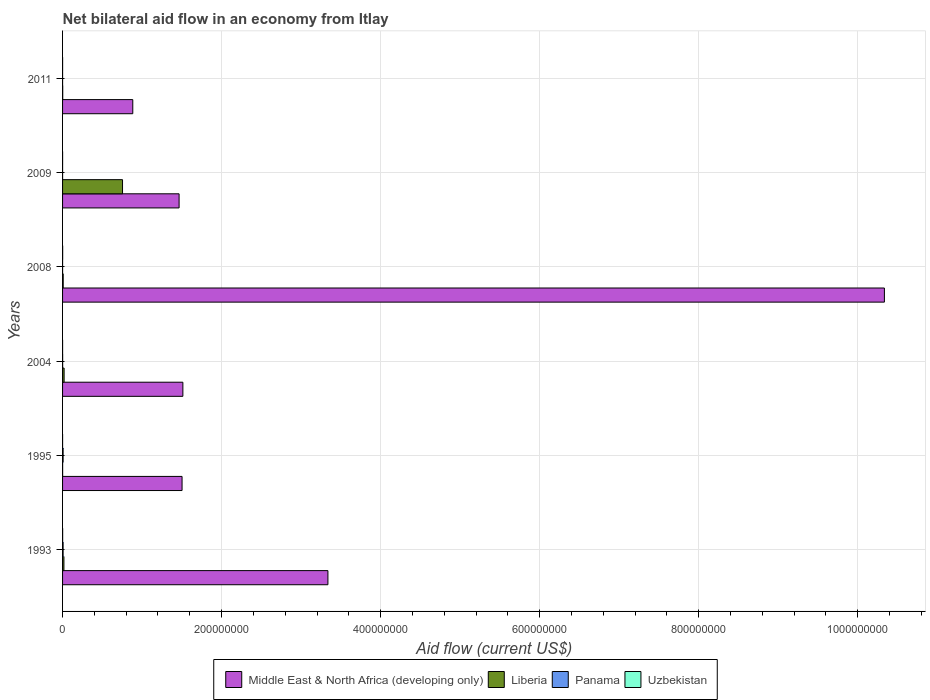Are the number of bars on each tick of the Y-axis equal?
Provide a short and direct response. Yes. What is the net bilateral aid flow in Uzbekistan in 1995?
Offer a very short reply. 10000. Across all years, what is the maximum net bilateral aid flow in Middle East & North Africa (developing only)?
Your answer should be compact. 1.03e+09. In which year was the net bilateral aid flow in Uzbekistan maximum?
Offer a very short reply. 2008. What is the total net bilateral aid flow in Panama in the graph?
Your response must be concise. 1.48e+06. What is the difference between the net bilateral aid flow in Panama in 1993 and the net bilateral aid flow in Middle East & North Africa (developing only) in 2008?
Give a very brief answer. -1.03e+09. What is the average net bilateral aid flow in Middle East & North Africa (developing only) per year?
Your answer should be compact. 3.17e+08. In the year 1995, what is the difference between the net bilateral aid flow in Uzbekistan and net bilateral aid flow in Liberia?
Provide a short and direct response. -7.00e+04. In how many years, is the net bilateral aid flow in Uzbekistan greater than 920000000 US$?
Make the answer very short. 0. What is the ratio of the net bilateral aid flow in Uzbekistan in 1993 to that in 2004?
Your answer should be compact. 9. Is the net bilateral aid flow in Uzbekistan in 1995 less than that in 2008?
Ensure brevity in your answer.  Yes. Is the difference between the net bilateral aid flow in Uzbekistan in 1993 and 2004 greater than the difference between the net bilateral aid flow in Liberia in 1993 and 2004?
Your response must be concise. Yes. What is the difference between the highest and the second highest net bilateral aid flow in Liberia?
Keep it short and to the point. 7.35e+07. What is the difference between the highest and the lowest net bilateral aid flow in Middle East & North Africa (developing only)?
Provide a succinct answer. 9.45e+08. Is it the case that in every year, the sum of the net bilateral aid flow in Uzbekistan and net bilateral aid flow in Middle East & North Africa (developing only) is greater than the sum of net bilateral aid flow in Liberia and net bilateral aid flow in Panama?
Offer a very short reply. Yes. What does the 1st bar from the top in 2004 represents?
Keep it short and to the point. Uzbekistan. What does the 1st bar from the bottom in 1993 represents?
Give a very brief answer. Middle East & North Africa (developing only). Is it the case that in every year, the sum of the net bilateral aid flow in Middle East & North Africa (developing only) and net bilateral aid flow in Liberia is greater than the net bilateral aid flow in Panama?
Make the answer very short. Yes. Are all the bars in the graph horizontal?
Your answer should be very brief. Yes. What is the difference between two consecutive major ticks on the X-axis?
Provide a short and direct response. 2.00e+08. Does the graph contain any zero values?
Keep it short and to the point. No. Does the graph contain grids?
Ensure brevity in your answer.  Yes. Where does the legend appear in the graph?
Keep it short and to the point. Bottom center. How many legend labels are there?
Provide a short and direct response. 4. What is the title of the graph?
Your answer should be very brief. Net bilateral aid flow in an economy from Itlay. Does "Faeroe Islands" appear as one of the legend labels in the graph?
Give a very brief answer. No. What is the Aid flow (current US$) of Middle East & North Africa (developing only) in 1993?
Ensure brevity in your answer.  3.34e+08. What is the Aid flow (current US$) in Liberia in 1993?
Offer a very short reply. 1.71e+06. What is the Aid flow (current US$) of Panama in 1993?
Offer a terse response. 6.80e+05. What is the Aid flow (current US$) in Uzbekistan in 1993?
Offer a terse response. 9.00e+04. What is the Aid flow (current US$) of Middle East & North Africa (developing only) in 1995?
Your answer should be compact. 1.50e+08. What is the Aid flow (current US$) in Panama in 1995?
Make the answer very short. 6.80e+05. What is the Aid flow (current US$) of Middle East & North Africa (developing only) in 2004?
Your response must be concise. 1.51e+08. What is the Aid flow (current US$) in Liberia in 2004?
Your answer should be very brief. 1.95e+06. What is the Aid flow (current US$) in Panama in 2004?
Offer a terse response. 9.00e+04. What is the Aid flow (current US$) in Middle East & North Africa (developing only) in 2008?
Your response must be concise. 1.03e+09. What is the Aid flow (current US$) of Liberia in 2008?
Provide a succinct answer. 8.10e+05. What is the Aid flow (current US$) in Uzbekistan in 2008?
Provide a short and direct response. 1.20e+05. What is the Aid flow (current US$) of Middle East & North Africa (developing only) in 2009?
Provide a short and direct response. 1.47e+08. What is the Aid flow (current US$) of Liberia in 2009?
Offer a terse response. 7.54e+07. What is the Aid flow (current US$) in Middle East & North Africa (developing only) in 2011?
Offer a terse response. 8.83e+07. Across all years, what is the maximum Aid flow (current US$) in Middle East & North Africa (developing only)?
Keep it short and to the point. 1.03e+09. Across all years, what is the maximum Aid flow (current US$) of Liberia?
Your answer should be very brief. 7.54e+07. Across all years, what is the maximum Aid flow (current US$) in Panama?
Give a very brief answer. 6.80e+05. Across all years, what is the minimum Aid flow (current US$) of Middle East & North Africa (developing only)?
Provide a short and direct response. 8.83e+07. What is the total Aid flow (current US$) of Middle East & North Africa (developing only) in the graph?
Provide a succinct answer. 1.90e+09. What is the total Aid flow (current US$) in Liberia in the graph?
Make the answer very short. 8.02e+07. What is the total Aid flow (current US$) in Panama in the graph?
Ensure brevity in your answer.  1.48e+06. What is the difference between the Aid flow (current US$) in Middle East & North Africa (developing only) in 1993 and that in 1995?
Your response must be concise. 1.83e+08. What is the difference between the Aid flow (current US$) of Liberia in 1993 and that in 1995?
Keep it short and to the point. 1.63e+06. What is the difference between the Aid flow (current US$) of Uzbekistan in 1993 and that in 1995?
Provide a short and direct response. 8.00e+04. What is the difference between the Aid flow (current US$) of Middle East & North Africa (developing only) in 1993 and that in 2004?
Offer a very short reply. 1.82e+08. What is the difference between the Aid flow (current US$) of Panama in 1993 and that in 2004?
Give a very brief answer. 5.90e+05. What is the difference between the Aid flow (current US$) in Middle East & North Africa (developing only) in 1993 and that in 2008?
Offer a terse response. -7.00e+08. What is the difference between the Aid flow (current US$) of Liberia in 1993 and that in 2008?
Ensure brevity in your answer.  9.00e+05. What is the difference between the Aid flow (current US$) of Panama in 1993 and that in 2008?
Provide a short and direct response. 6.70e+05. What is the difference between the Aid flow (current US$) of Middle East & North Africa (developing only) in 1993 and that in 2009?
Make the answer very short. 1.87e+08. What is the difference between the Aid flow (current US$) in Liberia in 1993 and that in 2009?
Ensure brevity in your answer.  -7.37e+07. What is the difference between the Aid flow (current US$) in Panama in 1993 and that in 2009?
Keep it short and to the point. 6.70e+05. What is the difference between the Aid flow (current US$) of Middle East & North Africa (developing only) in 1993 and that in 2011?
Make the answer very short. 2.45e+08. What is the difference between the Aid flow (current US$) of Liberia in 1993 and that in 2011?
Your answer should be compact. 1.52e+06. What is the difference between the Aid flow (current US$) in Panama in 1993 and that in 2011?
Ensure brevity in your answer.  6.70e+05. What is the difference between the Aid flow (current US$) in Middle East & North Africa (developing only) in 1995 and that in 2004?
Keep it short and to the point. -1.02e+06. What is the difference between the Aid flow (current US$) in Liberia in 1995 and that in 2004?
Provide a short and direct response. -1.87e+06. What is the difference between the Aid flow (current US$) of Panama in 1995 and that in 2004?
Give a very brief answer. 5.90e+05. What is the difference between the Aid flow (current US$) in Middle East & North Africa (developing only) in 1995 and that in 2008?
Ensure brevity in your answer.  -8.83e+08. What is the difference between the Aid flow (current US$) in Liberia in 1995 and that in 2008?
Your answer should be compact. -7.30e+05. What is the difference between the Aid flow (current US$) of Panama in 1995 and that in 2008?
Keep it short and to the point. 6.70e+05. What is the difference between the Aid flow (current US$) in Uzbekistan in 1995 and that in 2008?
Ensure brevity in your answer.  -1.10e+05. What is the difference between the Aid flow (current US$) in Middle East & North Africa (developing only) in 1995 and that in 2009?
Make the answer very short. 3.73e+06. What is the difference between the Aid flow (current US$) in Liberia in 1995 and that in 2009?
Your answer should be compact. -7.53e+07. What is the difference between the Aid flow (current US$) in Panama in 1995 and that in 2009?
Ensure brevity in your answer.  6.70e+05. What is the difference between the Aid flow (current US$) of Uzbekistan in 1995 and that in 2009?
Your response must be concise. -2.00e+04. What is the difference between the Aid flow (current US$) of Middle East & North Africa (developing only) in 1995 and that in 2011?
Your answer should be very brief. 6.20e+07. What is the difference between the Aid flow (current US$) of Liberia in 1995 and that in 2011?
Provide a short and direct response. -1.10e+05. What is the difference between the Aid flow (current US$) in Panama in 1995 and that in 2011?
Provide a short and direct response. 6.70e+05. What is the difference between the Aid flow (current US$) of Middle East & North Africa (developing only) in 2004 and that in 2008?
Give a very brief answer. -8.82e+08. What is the difference between the Aid flow (current US$) of Liberia in 2004 and that in 2008?
Your answer should be compact. 1.14e+06. What is the difference between the Aid flow (current US$) of Panama in 2004 and that in 2008?
Your answer should be very brief. 8.00e+04. What is the difference between the Aid flow (current US$) in Middle East & North Africa (developing only) in 2004 and that in 2009?
Offer a very short reply. 4.75e+06. What is the difference between the Aid flow (current US$) in Liberia in 2004 and that in 2009?
Offer a terse response. -7.35e+07. What is the difference between the Aid flow (current US$) of Panama in 2004 and that in 2009?
Keep it short and to the point. 8.00e+04. What is the difference between the Aid flow (current US$) of Uzbekistan in 2004 and that in 2009?
Ensure brevity in your answer.  -2.00e+04. What is the difference between the Aid flow (current US$) in Middle East & North Africa (developing only) in 2004 and that in 2011?
Make the answer very short. 6.30e+07. What is the difference between the Aid flow (current US$) of Liberia in 2004 and that in 2011?
Make the answer very short. 1.76e+06. What is the difference between the Aid flow (current US$) in Panama in 2004 and that in 2011?
Offer a terse response. 8.00e+04. What is the difference between the Aid flow (current US$) in Uzbekistan in 2004 and that in 2011?
Keep it short and to the point. -2.00e+04. What is the difference between the Aid flow (current US$) in Middle East & North Africa (developing only) in 2008 and that in 2009?
Give a very brief answer. 8.87e+08. What is the difference between the Aid flow (current US$) of Liberia in 2008 and that in 2009?
Provide a short and direct response. -7.46e+07. What is the difference between the Aid flow (current US$) of Panama in 2008 and that in 2009?
Make the answer very short. 0. What is the difference between the Aid flow (current US$) of Uzbekistan in 2008 and that in 2009?
Offer a very short reply. 9.00e+04. What is the difference between the Aid flow (current US$) in Middle East & North Africa (developing only) in 2008 and that in 2011?
Provide a short and direct response. 9.45e+08. What is the difference between the Aid flow (current US$) in Liberia in 2008 and that in 2011?
Make the answer very short. 6.20e+05. What is the difference between the Aid flow (current US$) of Panama in 2008 and that in 2011?
Your answer should be very brief. 0. What is the difference between the Aid flow (current US$) of Uzbekistan in 2008 and that in 2011?
Your answer should be compact. 9.00e+04. What is the difference between the Aid flow (current US$) of Middle East & North Africa (developing only) in 2009 and that in 2011?
Offer a very short reply. 5.82e+07. What is the difference between the Aid flow (current US$) of Liberia in 2009 and that in 2011?
Keep it short and to the point. 7.52e+07. What is the difference between the Aid flow (current US$) in Middle East & North Africa (developing only) in 1993 and the Aid flow (current US$) in Liberia in 1995?
Make the answer very short. 3.34e+08. What is the difference between the Aid flow (current US$) in Middle East & North Africa (developing only) in 1993 and the Aid flow (current US$) in Panama in 1995?
Keep it short and to the point. 3.33e+08. What is the difference between the Aid flow (current US$) in Middle East & North Africa (developing only) in 1993 and the Aid flow (current US$) in Uzbekistan in 1995?
Make the answer very short. 3.34e+08. What is the difference between the Aid flow (current US$) in Liberia in 1993 and the Aid flow (current US$) in Panama in 1995?
Your response must be concise. 1.03e+06. What is the difference between the Aid flow (current US$) of Liberia in 1993 and the Aid flow (current US$) of Uzbekistan in 1995?
Offer a very short reply. 1.70e+06. What is the difference between the Aid flow (current US$) in Panama in 1993 and the Aid flow (current US$) in Uzbekistan in 1995?
Your response must be concise. 6.70e+05. What is the difference between the Aid flow (current US$) in Middle East & North Africa (developing only) in 1993 and the Aid flow (current US$) in Liberia in 2004?
Your response must be concise. 3.32e+08. What is the difference between the Aid flow (current US$) in Middle East & North Africa (developing only) in 1993 and the Aid flow (current US$) in Panama in 2004?
Make the answer very short. 3.34e+08. What is the difference between the Aid flow (current US$) in Middle East & North Africa (developing only) in 1993 and the Aid flow (current US$) in Uzbekistan in 2004?
Provide a succinct answer. 3.34e+08. What is the difference between the Aid flow (current US$) of Liberia in 1993 and the Aid flow (current US$) of Panama in 2004?
Provide a succinct answer. 1.62e+06. What is the difference between the Aid flow (current US$) of Liberia in 1993 and the Aid flow (current US$) of Uzbekistan in 2004?
Offer a terse response. 1.70e+06. What is the difference between the Aid flow (current US$) of Panama in 1993 and the Aid flow (current US$) of Uzbekistan in 2004?
Make the answer very short. 6.70e+05. What is the difference between the Aid flow (current US$) of Middle East & North Africa (developing only) in 1993 and the Aid flow (current US$) of Liberia in 2008?
Keep it short and to the point. 3.33e+08. What is the difference between the Aid flow (current US$) of Middle East & North Africa (developing only) in 1993 and the Aid flow (current US$) of Panama in 2008?
Make the answer very short. 3.34e+08. What is the difference between the Aid flow (current US$) of Middle East & North Africa (developing only) in 1993 and the Aid flow (current US$) of Uzbekistan in 2008?
Provide a succinct answer. 3.34e+08. What is the difference between the Aid flow (current US$) in Liberia in 1993 and the Aid flow (current US$) in Panama in 2008?
Your answer should be very brief. 1.70e+06. What is the difference between the Aid flow (current US$) in Liberia in 1993 and the Aid flow (current US$) in Uzbekistan in 2008?
Keep it short and to the point. 1.59e+06. What is the difference between the Aid flow (current US$) in Panama in 1993 and the Aid flow (current US$) in Uzbekistan in 2008?
Offer a terse response. 5.60e+05. What is the difference between the Aid flow (current US$) in Middle East & North Africa (developing only) in 1993 and the Aid flow (current US$) in Liberia in 2009?
Your response must be concise. 2.58e+08. What is the difference between the Aid flow (current US$) in Middle East & North Africa (developing only) in 1993 and the Aid flow (current US$) in Panama in 2009?
Your response must be concise. 3.34e+08. What is the difference between the Aid flow (current US$) of Middle East & North Africa (developing only) in 1993 and the Aid flow (current US$) of Uzbekistan in 2009?
Your answer should be very brief. 3.34e+08. What is the difference between the Aid flow (current US$) in Liberia in 1993 and the Aid flow (current US$) in Panama in 2009?
Ensure brevity in your answer.  1.70e+06. What is the difference between the Aid flow (current US$) of Liberia in 1993 and the Aid flow (current US$) of Uzbekistan in 2009?
Your answer should be very brief. 1.68e+06. What is the difference between the Aid flow (current US$) in Panama in 1993 and the Aid flow (current US$) in Uzbekistan in 2009?
Make the answer very short. 6.50e+05. What is the difference between the Aid flow (current US$) in Middle East & North Africa (developing only) in 1993 and the Aid flow (current US$) in Liberia in 2011?
Your answer should be compact. 3.34e+08. What is the difference between the Aid flow (current US$) in Middle East & North Africa (developing only) in 1993 and the Aid flow (current US$) in Panama in 2011?
Provide a succinct answer. 3.34e+08. What is the difference between the Aid flow (current US$) in Middle East & North Africa (developing only) in 1993 and the Aid flow (current US$) in Uzbekistan in 2011?
Keep it short and to the point. 3.34e+08. What is the difference between the Aid flow (current US$) in Liberia in 1993 and the Aid flow (current US$) in Panama in 2011?
Ensure brevity in your answer.  1.70e+06. What is the difference between the Aid flow (current US$) of Liberia in 1993 and the Aid flow (current US$) of Uzbekistan in 2011?
Make the answer very short. 1.68e+06. What is the difference between the Aid flow (current US$) in Panama in 1993 and the Aid flow (current US$) in Uzbekistan in 2011?
Keep it short and to the point. 6.50e+05. What is the difference between the Aid flow (current US$) in Middle East & North Africa (developing only) in 1995 and the Aid flow (current US$) in Liberia in 2004?
Offer a very short reply. 1.48e+08. What is the difference between the Aid flow (current US$) of Middle East & North Africa (developing only) in 1995 and the Aid flow (current US$) of Panama in 2004?
Your answer should be very brief. 1.50e+08. What is the difference between the Aid flow (current US$) in Middle East & North Africa (developing only) in 1995 and the Aid flow (current US$) in Uzbekistan in 2004?
Give a very brief answer. 1.50e+08. What is the difference between the Aid flow (current US$) in Liberia in 1995 and the Aid flow (current US$) in Panama in 2004?
Make the answer very short. -10000. What is the difference between the Aid flow (current US$) in Liberia in 1995 and the Aid flow (current US$) in Uzbekistan in 2004?
Give a very brief answer. 7.00e+04. What is the difference between the Aid flow (current US$) in Panama in 1995 and the Aid flow (current US$) in Uzbekistan in 2004?
Ensure brevity in your answer.  6.70e+05. What is the difference between the Aid flow (current US$) of Middle East & North Africa (developing only) in 1995 and the Aid flow (current US$) of Liberia in 2008?
Provide a succinct answer. 1.49e+08. What is the difference between the Aid flow (current US$) in Middle East & North Africa (developing only) in 1995 and the Aid flow (current US$) in Panama in 2008?
Your answer should be very brief. 1.50e+08. What is the difference between the Aid flow (current US$) of Middle East & North Africa (developing only) in 1995 and the Aid flow (current US$) of Uzbekistan in 2008?
Give a very brief answer. 1.50e+08. What is the difference between the Aid flow (current US$) of Liberia in 1995 and the Aid flow (current US$) of Uzbekistan in 2008?
Ensure brevity in your answer.  -4.00e+04. What is the difference between the Aid flow (current US$) of Panama in 1995 and the Aid flow (current US$) of Uzbekistan in 2008?
Your answer should be very brief. 5.60e+05. What is the difference between the Aid flow (current US$) in Middle East & North Africa (developing only) in 1995 and the Aid flow (current US$) in Liberia in 2009?
Your response must be concise. 7.49e+07. What is the difference between the Aid flow (current US$) in Middle East & North Africa (developing only) in 1995 and the Aid flow (current US$) in Panama in 2009?
Provide a short and direct response. 1.50e+08. What is the difference between the Aid flow (current US$) of Middle East & North Africa (developing only) in 1995 and the Aid flow (current US$) of Uzbekistan in 2009?
Offer a very short reply. 1.50e+08. What is the difference between the Aid flow (current US$) in Liberia in 1995 and the Aid flow (current US$) in Uzbekistan in 2009?
Ensure brevity in your answer.  5.00e+04. What is the difference between the Aid flow (current US$) in Panama in 1995 and the Aid flow (current US$) in Uzbekistan in 2009?
Ensure brevity in your answer.  6.50e+05. What is the difference between the Aid flow (current US$) in Middle East & North Africa (developing only) in 1995 and the Aid flow (current US$) in Liberia in 2011?
Provide a short and direct response. 1.50e+08. What is the difference between the Aid flow (current US$) in Middle East & North Africa (developing only) in 1995 and the Aid flow (current US$) in Panama in 2011?
Your answer should be very brief. 1.50e+08. What is the difference between the Aid flow (current US$) of Middle East & North Africa (developing only) in 1995 and the Aid flow (current US$) of Uzbekistan in 2011?
Your response must be concise. 1.50e+08. What is the difference between the Aid flow (current US$) in Liberia in 1995 and the Aid flow (current US$) in Panama in 2011?
Offer a terse response. 7.00e+04. What is the difference between the Aid flow (current US$) of Liberia in 1995 and the Aid flow (current US$) of Uzbekistan in 2011?
Provide a succinct answer. 5.00e+04. What is the difference between the Aid flow (current US$) in Panama in 1995 and the Aid flow (current US$) in Uzbekistan in 2011?
Provide a short and direct response. 6.50e+05. What is the difference between the Aid flow (current US$) in Middle East & North Africa (developing only) in 2004 and the Aid flow (current US$) in Liberia in 2008?
Provide a short and direct response. 1.50e+08. What is the difference between the Aid flow (current US$) in Middle East & North Africa (developing only) in 2004 and the Aid flow (current US$) in Panama in 2008?
Offer a terse response. 1.51e+08. What is the difference between the Aid flow (current US$) of Middle East & North Africa (developing only) in 2004 and the Aid flow (current US$) of Uzbekistan in 2008?
Offer a terse response. 1.51e+08. What is the difference between the Aid flow (current US$) of Liberia in 2004 and the Aid flow (current US$) of Panama in 2008?
Your answer should be very brief. 1.94e+06. What is the difference between the Aid flow (current US$) in Liberia in 2004 and the Aid flow (current US$) in Uzbekistan in 2008?
Your response must be concise. 1.83e+06. What is the difference between the Aid flow (current US$) of Middle East & North Africa (developing only) in 2004 and the Aid flow (current US$) of Liberia in 2009?
Make the answer very short. 7.59e+07. What is the difference between the Aid flow (current US$) of Middle East & North Africa (developing only) in 2004 and the Aid flow (current US$) of Panama in 2009?
Make the answer very short. 1.51e+08. What is the difference between the Aid flow (current US$) in Middle East & North Africa (developing only) in 2004 and the Aid flow (current US$) in Uzbekistan in 2009?
Provide a short and direct response. 1.51e+08. What is the difference between the Aid flow (current US$) in Liberia in 2004 and the Aid flow (current US$) in Panama in 2009?
Make the answer very short. 1.94e+06. What is the difference between the Aid flow (current US$) of Liberia in 2004 and the Aid flow (current US$) of Uzbekistan in 2009?
Provide a succinct answer. 1.92e+06. What is the difference between the Aid flow (current US$) in Panama in 2004 and the Aid flow (current US$) in Uzbekistan in 2009?
Offer a very short reply. 6.00e+04. What is the difference between the Aid flow (current US$) in Middle East & North Africa (developing only) in 2004 and the Aid flow (current US$) in Liberia in 2011?
Your response must be concise. 1.51e+08. What is the difference between the Aid flow (current US$) in Middle East & North Africa (developing only) in 2004 and the Aid flow (current US$) in Panama in 2011?
Offer a very short reply. 1.51e+08. What is the difference between the Aid flow (current US$) of Middle East & North Africa (developing only) in 2004 and the Aid flow (current US$) of Uzbekistan in 2011?
Keep it short and to the point. 1.51e+08. What is the difference between the Aid flow (current US$) in Liberia in 2004 and the Aid flow (current US$) in Panama in 2011?
Provide a short and direct response. 1.94e+06. What is the difference between the Aid flow (current US$) of Liberia in 2004 and the Aid flow (current US$) of Uzbekistan in 2011?
Offer a terse response. 1.92e+06. What is the difference between the Aid flow (current US$) of Panama in 2004 and the Aid flow (current US$) of Uzbekistan in 2011?
Keep it short and to the point. 6.00e+04. What is the difference between the Aid flow (current US$) in Middle East & North Africa (developing only) in 2008 and the Aid flow (current US$) in Liberia in 2009?
Offer a terse response. 9.58e+08. What is the difference between the Aid flow (current US$) of Middle East & North Africa (developing only) in 2008 and the Aid flow (current US$) of Panama in 2009?
Make the answer very short. 1.03e+09. What is the difference between the Aid flow (current US$) of Middle East & North Africa (developing only) in 2008 and the Aid flow (current US$) of Uzbekistan in 2009?
Offer a very short reply. 1.03e+09. What is the difference between the Aid flow (current US$) in Liberia in 2008 and the Aid flow (current US$) in Uzbekistan in 2009?
Give a very brief answer. 7.80e+05. What is the difference between the Aid flow (current US$) of Panama in 2008 and the Aid flow (current US$) of Uzbekistan in 2009?
Your answer should be compact. -2.00e+04. What is the difference between the Aid flow (current US$) of Middle East & North Africa (developing only) in 2008 and the Aid flow (current US$) of Liberia in 2011?
Your answer should be very brief. 1.03e+09. What is the difference between the Aid flow (current US$) in Middle East & North Africa (developing only) in 2008 and the Aid flow (current US$) in Panama in 2011?
Your answer should be very brief. 1.03e+09. What is the difference between the Aid flow (current US$) of Middle East & North Africa (developing only) in 2008 and the Aid flow (current US$) of Uzbekistan in 2011?
Give a very brief answer. 1.03e+09. What is the difference between the Aid flow (current US$) of Liberia in 2008 and the Aid flow (current US$) of Panama in 2011?
Your answer should be very brief. 8.00e+05. What is the difference between the Aid flow (current US$) in Liberia in 2008 and the Aid flow (current US$) in Uzbekistan in 2011?
Make the answer very short. 7.80e+05. What is the difference between the Aid flow (current US$) of Panama in 2008 and the Aid flow (current US$) of Uzbekistan in 2011?
Provide a short and direct response. -2.00e+04. What is the difference between the Aid flow (current US$) in Middle East & North Africa (developing only) in 2009 and the Aid flow (current US$) in Liberia in 2011?
Give a very brief answer. 1.46e+08. What is the difference between the Aid flow (current US$) in Middle East & North Africa (developing only) in 2009 and the Aid flow (current US$) in Panama in 2011?
Make the answer very short. 1.47e+08. What is the difference between the Aid flow (current US$) in Middle East & North Africa (developing only) in 2009 and the Aid flow (current US$) in Uzbekistan in 2011?
Provide a short and direct response. 1.47e+08. What is the difference between the Aid flow (current US$) in Liberia in 2009 and the Aid flow (current US$) in Panama in 2011?
Give a very brief answer. 7.54e+07. What is the difference between the Aid flow (current US$) of Liberia in 2009 and the Aid flow (current US$) of Uzbekistan in 2011?
Your response must be concise. 7.54e+07. What is the difference between the Aid flow (current US$) of Panama in 2009 and the Aid flow (current US$) of Uzbekistan in 2011?
Ensure brevity in your answer.  -2.00e+04. What is the average Aid flow (current US$) in Middle East & North Africa (developing only) per year?
Your answer should be compact. 3.17e+08. What is the average Aid flow (current US$) of Liberia per year?
Your answer should be very brief. 1.34e+07. What is the average Aid flow (current US$) in Panama per year?
Keep it short and to the point. 2.47e+05. What is the average Aid flow (current US$) in Uzbekistan per year?
Your response must be concise. 4.83e+04. In the year 1993, what is the difference between the Aid flow (current US$) in Middle East & North Africa (developing only) and Aid flow (current US$) in Liberia?
Your response must be concise. 3.32e+08. In the year 1993, what is the difference between the Aid flow (current US$) in Middle East & North Africa (developing only) and Aid flow (current US$) in Panama?
Your response must be concise. 3.33e+08. In the year 1993, what is the difference between the Aid flow (current US$) of Middle East & North Africa (developing only) and Aid flow (current US$) of Uzbekistan?
Ensure brevity in your answer.  3.34e+08. In the year 1993, what is the difference between the Aid flow (current US$) in Liberia and Aid flow (current US$) in Panama?
Provide a short and direct response. 1.03e+06. In the year 1993, what is the difference between the Aid flow (current US$) of Liberia and Aid flow (current US$) of Uzbekistan?
Your answer should be very brief. 1.62e+06. In the year 1993, what is the difference between the Aid flow (current US$) in Panama and Aid flow (current US$) in Uzbekistan?
Provide a succinct answer. 5.90e+05. In the year 1995, what is the difference between the Aid flow (current US$) in Middle East & North Africa (developing only) and Aid flow (current US$) in Liberia?
Keep it short and to the point. 1.50e+08. In the year 1995, what is the difference between the Aid flow (current US$) in Middle East & North Africa (developing only) and Aid flow (current US$) in Panama?
Your response must be concise. 1.50e+08. In the year 1995, what is the difference between the Aid flow (current US$) in Middle East & North Africa (developing only) and Aid flow (current US$) in Uzbekistan?
Ensure brevity in your answer.  1.50e+08. In the year 1995, what is the difference between the Aid flow (current US$) of Liberia and Aid flow (current US$) of Panama?
Ensure brevity in your answer.  -6.00e+05. In the year 1995, what is the difference between the Aid flow (current US$) of Liberia and Aid flow (current US$) of Uzbekistan?
Your answer should be compact. 7.00e+04. In the year 1995, what is the difference between the Aid flow (current US$) in Panama and Aid flow (current US$) in Uzbekistan?
Provide a short and direct response. 6.70e+05. In the year 2004, what is the difference between the Aid flow (current US$) in Middle East & North Africa (developing only) and Aid flow (current US$) in Liberia?
Provide a succinct answer. 1.49e+08. In the year 2004, what is the difference between the Aid flow (current US$) of Middle East & North Africa (developing only) and Aid flow (current US$) of Panama?
Give a very brief answer. 1.51e+08. In the year 2004, what is the difference between the Aid flow (current US$) of Middle East & North Africa (developing only) and Aid flow (current US$) of Uzbekistan?
Your answer should be very brief. 1.51e+08. In the year 2004, what is the difference between the Aid flow (current US$) of Liberia and Aid flow (current US$) of Panama?
Make the answer very short. 1.86e+06. In the year 2004, what is the difference between the Aid flow (current US$) of Liberia and Aid flow (current US$) of Uzbekistan?
Give a very brief answer. 1.94e+06. In the year 2004, what is the difference between the Aid flow (current US$) in Panama and Aid flow (current US$) in Uzbekistan?
Give a very brief answer. 8.00e+04. In the year 2008, what is the difference between the Aid flow (current US$) of Middle East & North Africa (developing only) and Aid flow (current US$) of Liberia?
Provide a succinct answer. 1.03e+09. In the year 2008, what is the difference between the Aid flow (current US$) in Middle East & North Africa (developing only) and Aid flow (current US$) in Panama?
Ensure brevity in your answer.  1.03e+09. In the year 2008, what is the difference between the Aid flow (current US$) in Middle East & North Africa (developing only) and Aid flow (current US$) in Uzbekistan?
Your answer should be compact. 1.03e+09. In the year 2008, what is the difference between the Aid flow (current US$) in Liberia and Aid flow (current US$) in Uzbekistan?
Make the answer very short. 6.90e+05. In the year 2008, what is the difference between the Aid flow (current US$) of Panama and Aid flow (current US$) of Uzbekistan?
Offer a very short reply. -1.10e+05. In the year 2009, what is the difference between the Aid flow (current US$) in Middle East & North Africa (developing only) and Aid flow (current US$) in Liberia?
Make the answer very short. 7.11e+07. In the year 2009, what is the difference between the Aid flow (current US$) in Middle East & North Africa (developing only) and Aid flow (current US$) in Panama?
Your answer should be compact. 1.47e+08. In the year 2009, what is the difference between the Aid flow (current US$) in Middle East & North Africa (developing only) and Aid flow (current US$) in Uzbekistan?
Your answer should be very brief. 1.47e+08. In the year 2009, what is the difference between the Aid flow (current US$) in Liberia and Aid flow (current US$) in Panama?
Your answer should be compact. 7.54e+07. In the year 2009, what is the difference between the Aid flow (current US$) of Liberia and Aid flow (current US$) of Uzbekistan?
Keep it short and to the point. 7.54e+07. In the year 2009, what is the difference between the Aid flow (current US$) of Panama and Aid flow (current US$) of Uzbekistan?
Give a very brief answer. -2.00e+04. In the year 2011, what is the difference between the Aid flow (current US$) in Middle East & North Africa (developing only) and Aid flow (current US$) in Liberia?
Offer a terse response. 8.81e+07. In the year 2011, what is the difference between the Aid flow (current US$) in Middle East & North Africa (developing only) and Aid flow (current US$) in Panama?
Offer a very short reply. 8.83e+07. In the year 2011, what is the difference between the Aid flow (current US$) of Middle East & North Africa (developing only) and Aid flow (current US$) of Uzbekistan?
Your answer should be compact. 8.83e+07. What is the ratio of the Aid flow (current US$) in Middle East & North Africa (developing only) in 1993 to that in 1995?
Keep it short and to the point. 2.22. What is the ratio of the Aid flow (current US$) of Liberia in 1993 to that in 1995?
Ensure brevity in your answer.  21.38. What is the ratio of the Aid flow (current US$) in Panama in 1993 to that in 1995?
Provide a succinct answer. 1. What is the ratio of the Aid flow (current US$) of Uzbekistan in 1993 to that in 1995?
Offer a terse response. 9. What is the ratio of the Aid flow (current US$) in Middle East & North Africa (developing only) in 1993 to that in 2004?
Ensure brevity in your answer.  2.21. What is the ratio of the Aid flow (current US$) in Liberia in 1993 to that in 2004?
Give a very brief answer. 0.88. What is the ratio of the Aid flow (current US$) of Panama in 1993 to that in 2004?
Ensure brevity in your answer.  7.56. What is the ratio of the Aid flow (current US$) in Middle East & North Africa (developing only) in 1993 to that in 2008?
Offer a terse response. 0.32. What is the ratio of the Aid flow (current US$) in Liberia in 1993 to that in 2008?
Offer a very short reply. 2.11. What is the ratio of the Aid flow (current US$) in Panama in 1993 to that in 2008?
Your answer should be very brief. 68. What is the ratio of the Aid flow (current US$) of Middle East & North Africa (developing only) in 1993 to that in 2009?
Make the answer very short. 2.28. What is the ratio of the Aid flow (current US$) in Liberia in 1993 to that in 2009?
Keep it short and to the point. 0.02. What is the ratio of the Aid flow (current US$) of Uzbekistan in 1993 to that in 2009?
Make the answer very short. 3. What is the ratio of the Aid flow (current US$) in Middle East & North Africa (developing only) in 1993 to that in 2011?
Ensure brevity in your answer.  3.78. What is the ratio of the Aid flow (current US$) in Panama in 1993 to that in 2011?
Make the answer very short. 68. What is the ratio of the Aid flow (current US$) in Liberia in 1995 to that in 2004?
Your answer should be compact. 0.04. What is the ratio of the Aid flow (current US$) in Panama in 1995 to that in 2004?
Your answer should be very brief. 7.56. What is the ratio of the Aid flow (current US$) of Uzbekistan in 1995 to that in 2004?
Provide a succinct answer. 1. What is the ratio of the Aid flow (current US$) in Middle East & North Africa (developing only) in 1995 to that in 2008?
Your answer should be very brief. 0.15. What is the ratio of the Aid flow (current US$) in Liberia in 1995 to that in 2008?
Give a very brief answer. 0.1. What is the ratio of the Aid flow (current US$) of Panama in 1995 to that in 2008?
Give a very brief answer. 68. What is the ratio of the Aid flow (current US$) in Uzbekistan in 1995 to that in 2008?
Offer a terse response. 0.08. What is the ratio of the Aid flow (current US$) in Middle East & North Africa (developing only) in 1995 to that in 2009?
Your response must be concise. 1.03. What is the ratio of the Aid flow (current US$) in Liberia in 1995 to that in 2009?
Offer a very short reply. 0. What is the ratio of the Aid flow (current US$) in Uzbekistan in 1995 to that in 2009?
Give a very brief answer. 0.33. What is the ratio of the Aid flow (current US$) in Middle East & North Africa (developing only) in 1995 to that in 2011?
Provide a succinct answer. 1.7. What is the ratio of the Aid flow (current US$) in Liberia in 1995 to that in 2011?
Offer a very short reply. 0.42. What is the ratio of the Aid flow (current US$) in Uzbekistan in 1995 to that in 2011?
Make the answer very short. 0.33. What is the ratio of the Aid flow (current US$) of Middle East & North Africa (developing only) in 2004 to that in 2008?
Offer a terse response. 0.15. What is the ratio of the Aid flow (current US$) of Liberia in 2004 to that in 2008?
Your answer should be compact. 2.41. What is the ratio of the Aid flow (current US$) of Panama in 2004 to that in 2008?
Keep it short and to the point. 9. What is the ratio of the Aid flow (current US$) of Uzbekistan in 2004 to that in 2008?
Provide a succinct answer. 0.08. What is the ratio of the Aid flow (current US$) of Middle East & North Africa (developing only) in 2004 to that in 2009?
Offer a very short reply. 1.03. What is the ratio of the Aid flow (current US$) of Liberia in 2004 to that in 2009?
Make the answer very short. 0.03. What is the ratio of the Aid flow (current US$) of Panama in 2004 to that in 2009?
Provide a short and direct response. 9. What is the ratio of the Aid flow (current US$) of Middle East & North Africa (developing only) in 2004 to that in 2011?
Your response must be concise. 1.71. What is the ratio of the Aid flow (current US$) in Liberia in 2004 to that in 2011?
Offer a terse response. 10.26. What is the ratio of the Aid flow (current US$) of Uzbekistan in 2004 to that in 2011?
Ensure brevity in your answer.  0.33. What is the ratio of the Aid flow (current US$) in Middle East & North Africa (developing only) in 2008 to that in 2009?
Your answer should be very brief. 7.05. What is the ratio of the Aid flow (current US$) of Liberia in 2008 to that in 2009?
Ensure brevity in your answer.  0.01. What is the ratio of the Aid flow (current US$) in Middle East & North Africa (developing only) in 2008 to that in 2011?
Your answer should be very brief. 11.7. What is the ratio of the Aid flow (current US$) in Liberia in 2008 to that in 2011?
Ensure brevity in your answer.  4.26. What is the ratio of the Aid flow (current US$) of Middle East & North Africa (developing only) in 2009 to that in 2011?
Your answer should be compact. 1.66. What is the ratio of the Aid flow (current US$) in Liberia in 2009 to that in 2011?
Give a very brief answer. 396.89. What is the ratio of the Aid flow (current US$) in Uzbekistan in 2009 to that in 2011?
Provide a short and direct response. 1. What is the difference between the highest and the second highest Aid flow (current US$) of Middle East & North Africa (developing only)?
Your answer should be compact. 7.00e+08. What is the difference between the highest and the second highest Aid flow (current US$) of Liberia?
Your response must be concise. 7.35e+07. What is the difference between the highest and the second highest Aid flow (current US$) in Uzbekistan?
Your answer should be very brief. 3.00e+04. What is the difference between the highest and the lowest Aid flow (current US$) of Middle East & North Africa (developing only)?
Keep it short and to the point. 9.45e+08. What is the difference between the highest and the lowest Aid flow (current US$) of Liberia?
Give a very brief answer. 7.53e+07. What is the difference between the highest and the lowest Aid flow (current US$) of Panama?
Provide a succinct answer. 6.70e+05. 